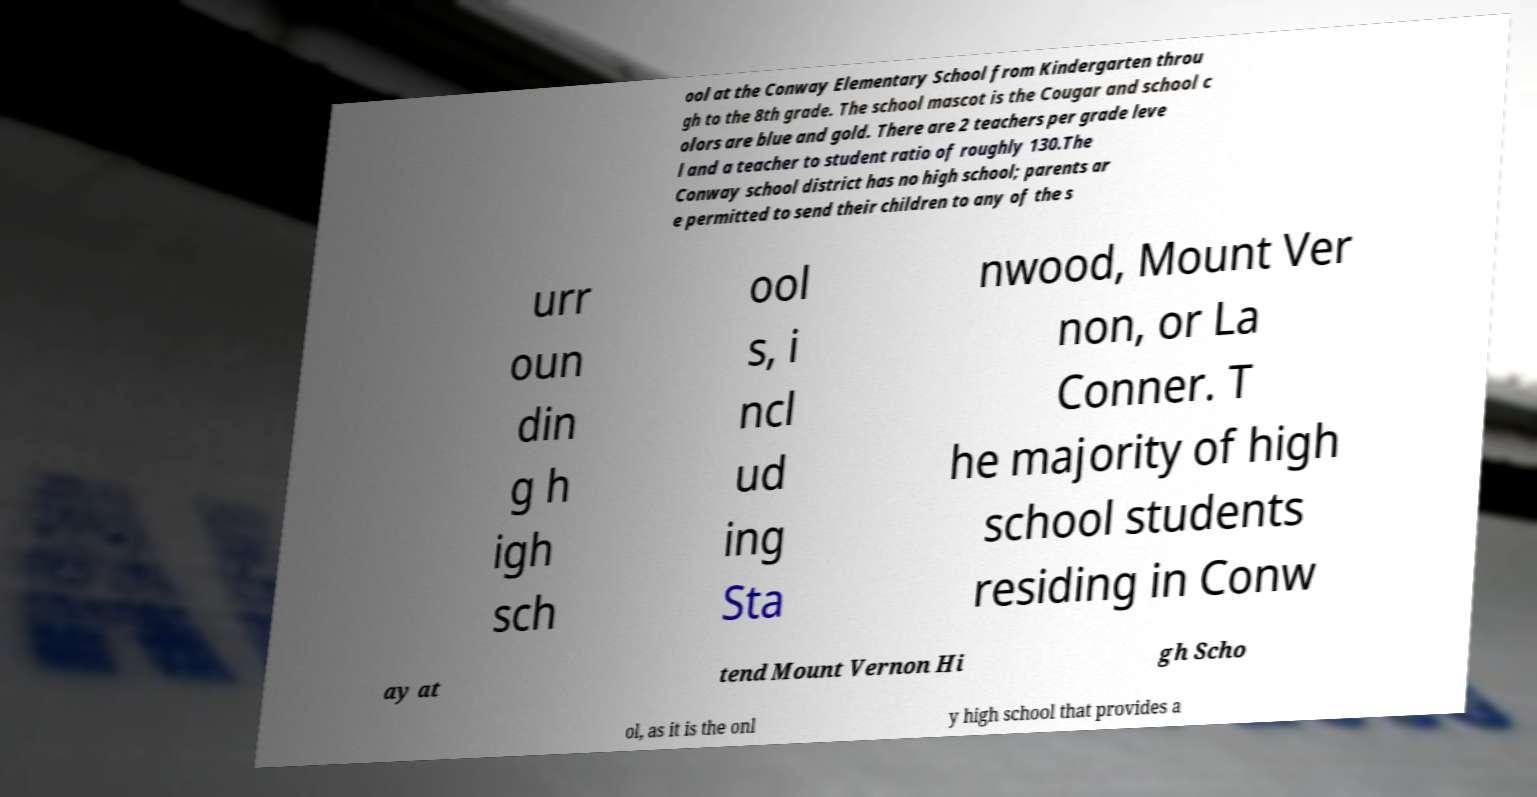Please read and relay the text visible in this image. What does it say? ool at the Conway Elementary School from Kindergarten throu gh to the 8th grade. The school mascot is the Cougar and school c olors are blue and gold. There are 2 teachers per grade leve l and a teacher to student ratio of roughly 130.The Conway school district has no high school; parents ar e permitted to send their children to any of the s urr oun din g h igh sch ool s, i ncl ud ing Sta nwood, Mount Ver non, or La Conner. T he majority of high school students residing in Conw ay at tend Mount Vernon Hi gh Scho ol, as it is the onl y high school that provides a 